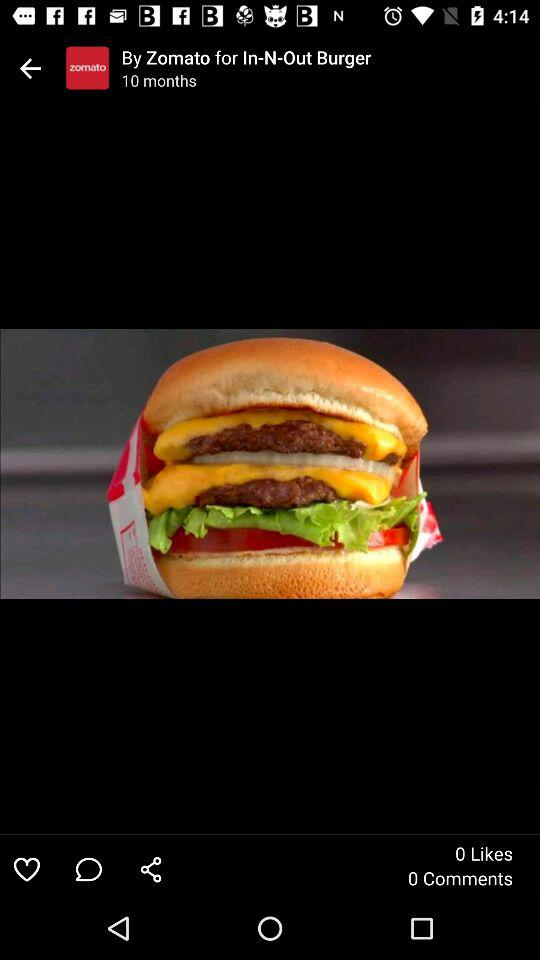Who took the photograph?
When the provided information is insufficient, respond with <no answer>. <no answer> 